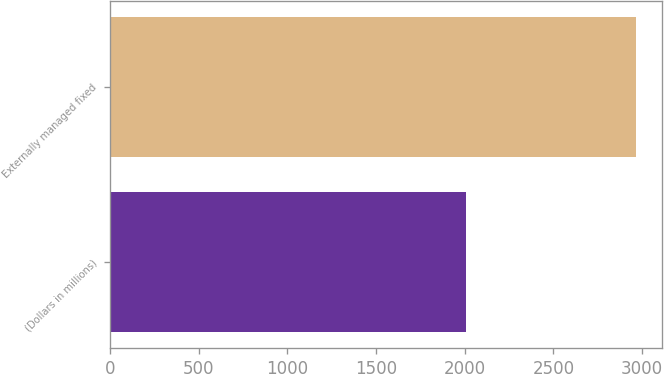Convert chart to OTSL. <chart><loc_0><loc_0><loc_500><loc_500><bar_chart><fcel>(Dollars in millions)<fcel>Externally managed fixed<nl><fcel>2007<fcel>2963<nl></chart> 